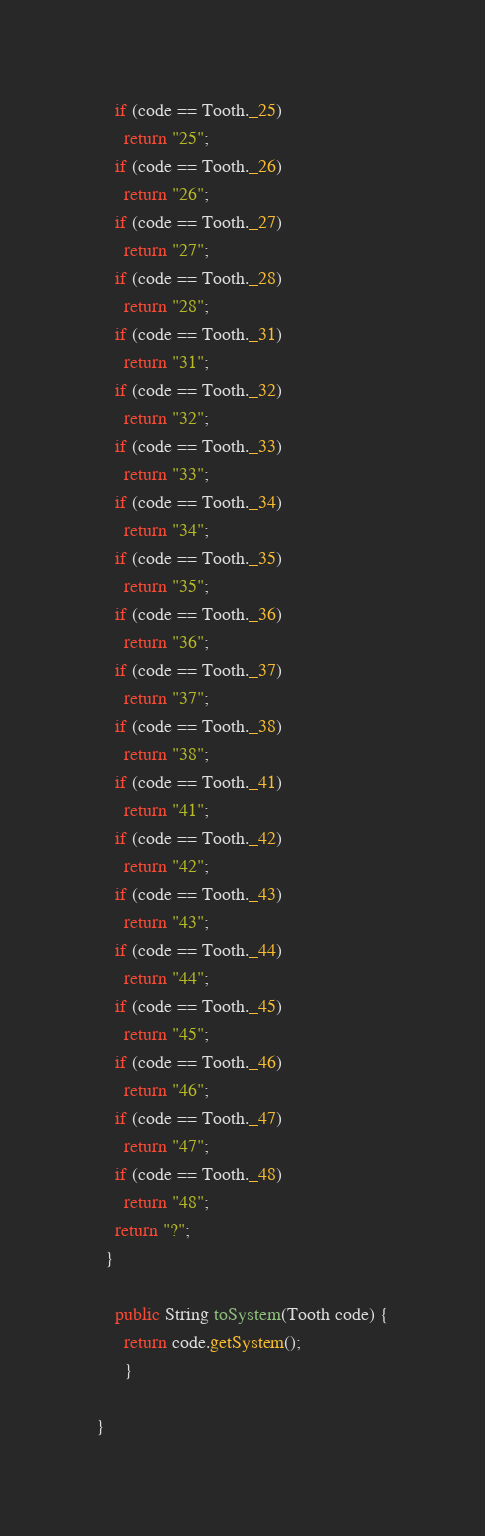<code> <loc_0><loc_0><loc_500><loc_500><_Java_>    if (code == Tooth._25)
      return "25";
    if (code == Tooth._26)
      return "26";
    if (code == Tooth._27)
      return "27";
    if (code == Tooth._28)
      return "28";
    if (code == Tooth._31)
      return "31";
    if (code == Tooth._32)
      return "32";
    if (code == Tooth._33)
      return "33";
    if (code == Tooth._34)
      return "34";
    if (code == Tooth._35)
      return "35";
    if (code == Tooth._36)
      return "36";
    if (code == Tooth._37)
      return "37";
    if (code == Tooth._38)
      return "38";
    if (code == Tooth._41)
      return "41";
    if (code == Tooth._42)
      return "42";
    if (code == Tooth._43)
      return "43";
    if (code == Tooth._44)
      return "44";
    if (code == Tooth._45)
      return "45";
    if (code == Tooth._46)
      return "46";
    if (code == Tooth._47)
      return "47";
    if (code == Tooth._48)
      return "48";
    return "?";
  }

    public String toSystem(Tooth code) {
      return code.getSystem();
      }

}

</code> 